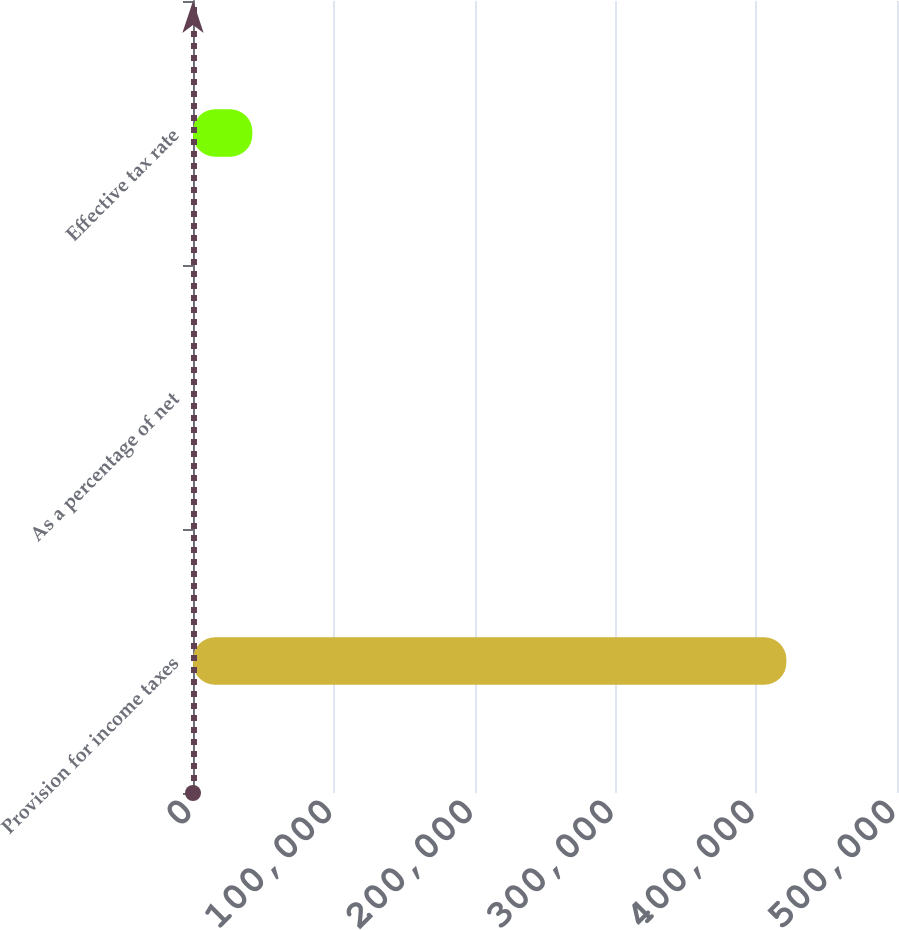<chart> <loc_0><loc_0><loc_500><loc_500><bar_chart><fcel>Provision for income taxes<fcel>As a percentage of net<fcel>Effective tax rate<nl><fcel>421418<fcel>7.1<fcel>42148.2<nl></chart> 